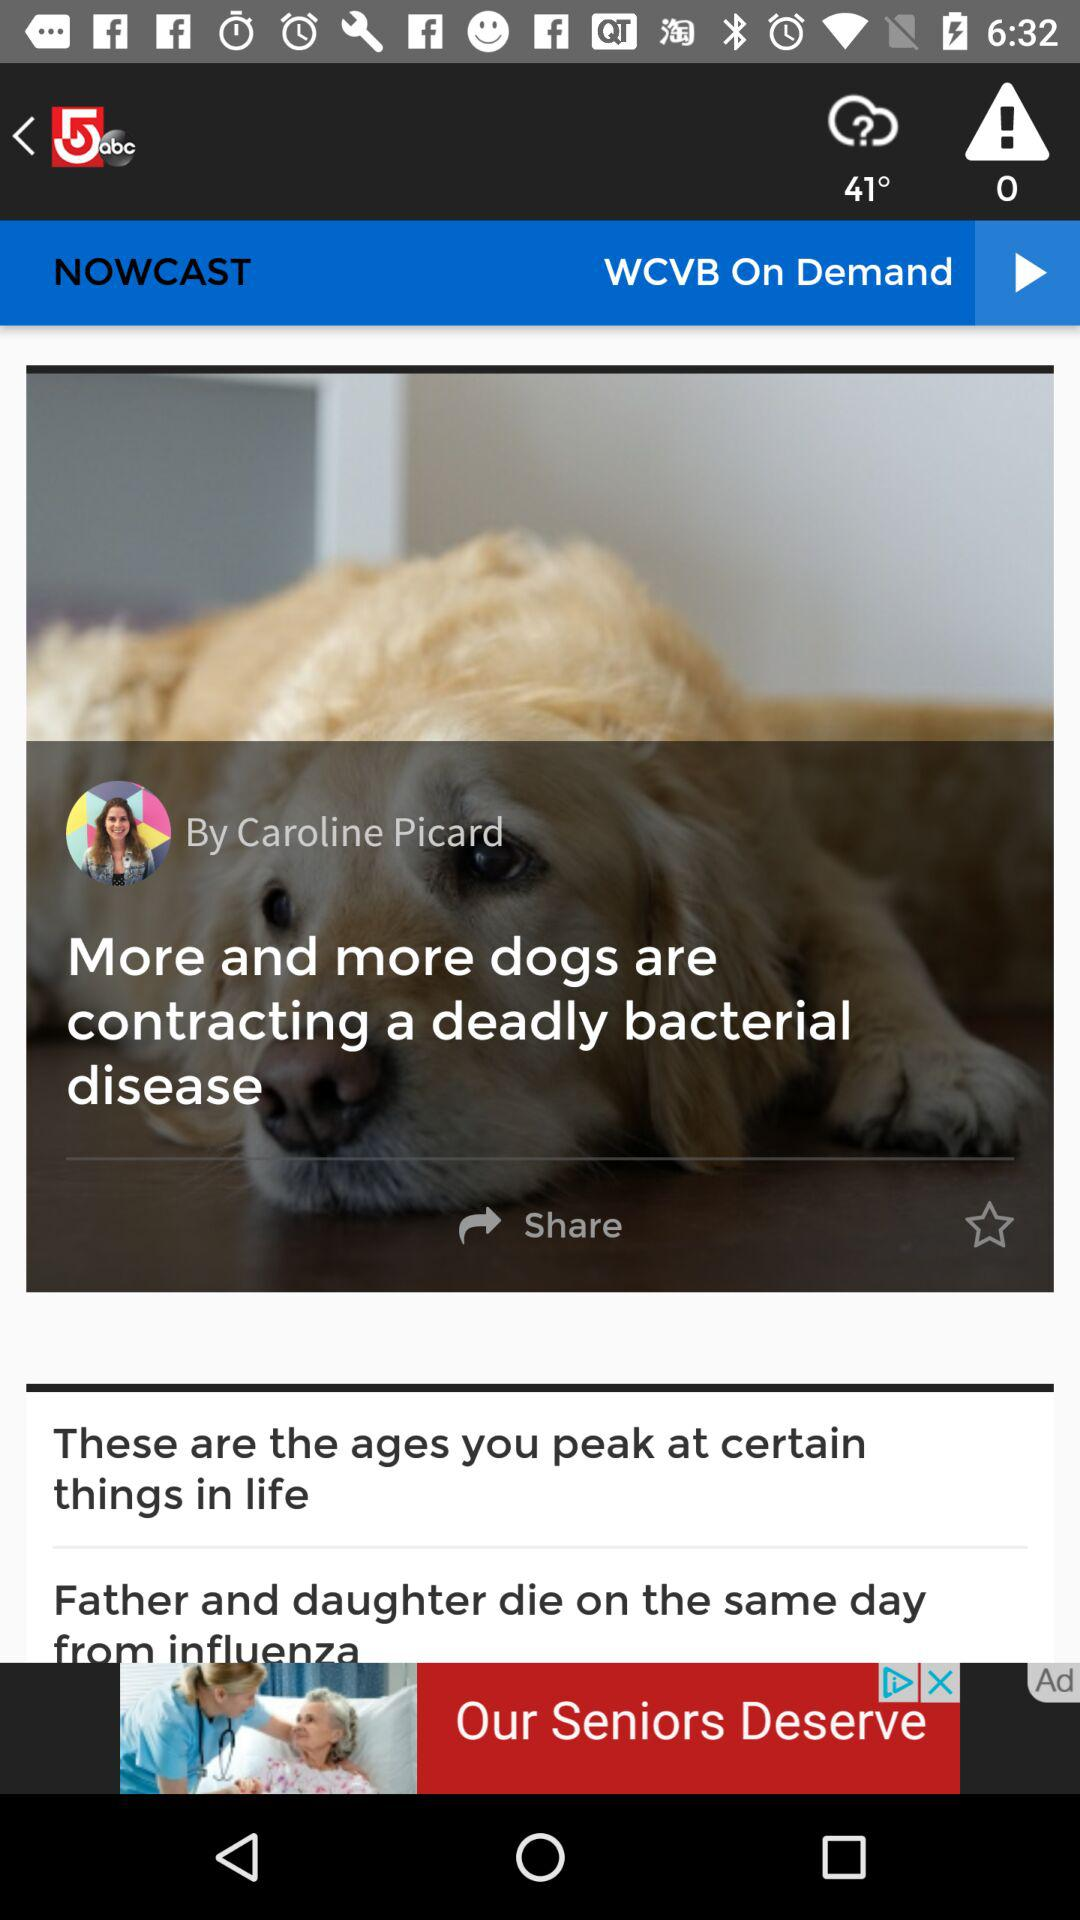What is the temperature? The temperature is 41°. 